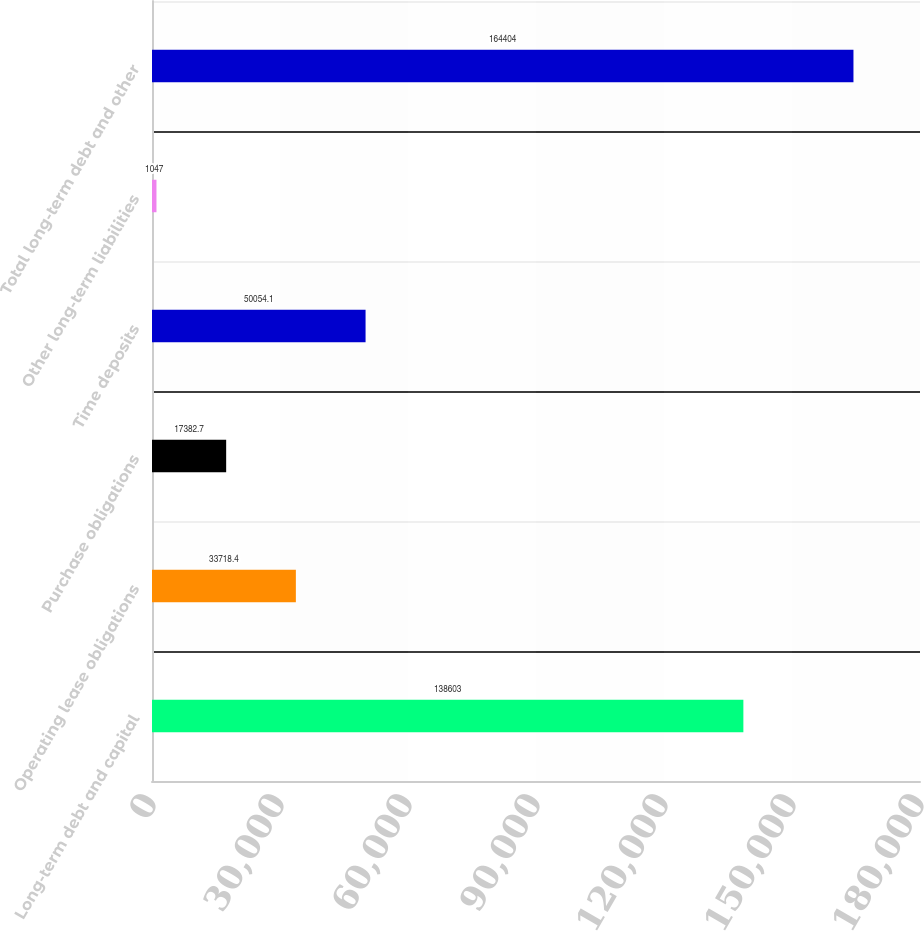<chart> <loc_0><loc_0><loc_500><loc_500><bar_chart><fcel>Long-term debt and capital<fcel>Operating lease obligations<fcel>Purchase obligations<fcel>Time deposits<fcel>Other long-term liabilities<fcel>Total long-term debt and other<nl><fcel>138603<fcel>33718.4<fcel>17382.7<fcel>50054.1<fcel>1047<fcel>164404<nl></chart> 